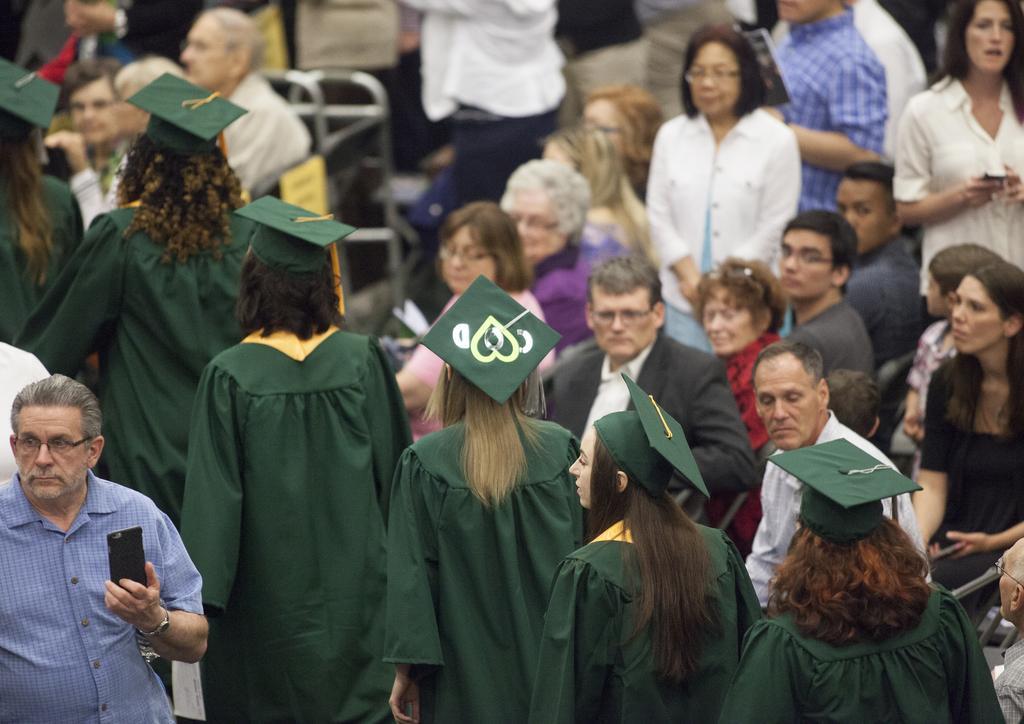Please provide a concise description of this image. In the image few people are standing and sitting and watching and they are holding something in their hands. 